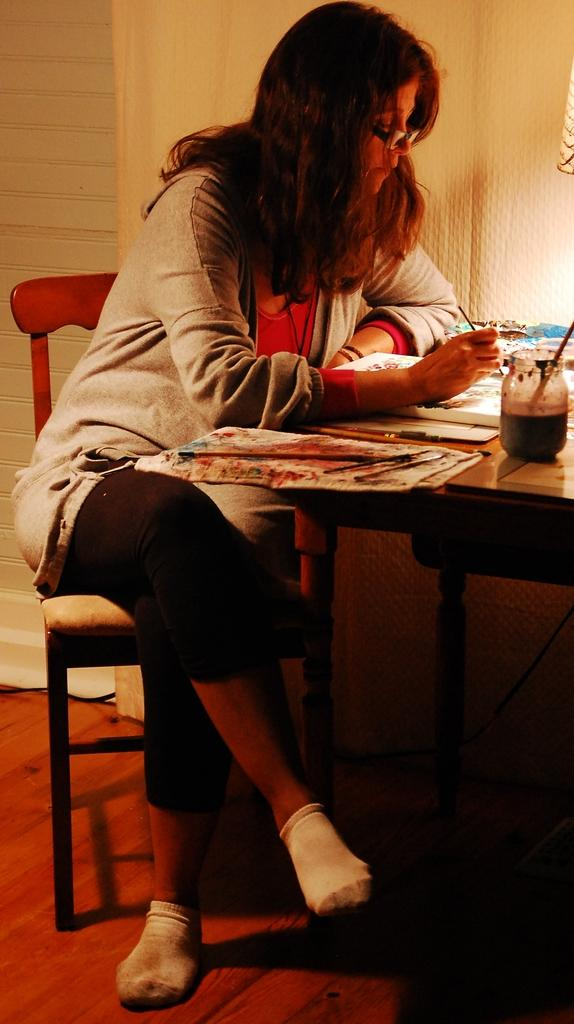Who is the main subject in the image? There is a lady in the image. What is the lady doing in the image? The lady is sitting on a table and a desk. What can be seen on the table in the image? There are many colors placed on the table. What type of fear does the lady express in the image? There is no indication of fear in the image; the lady is simply sitting on a table and a desk. What kind of flag is present in the image? There is no flag present in the image; it features a lady sitting on a table and a desk with colors on the table. 